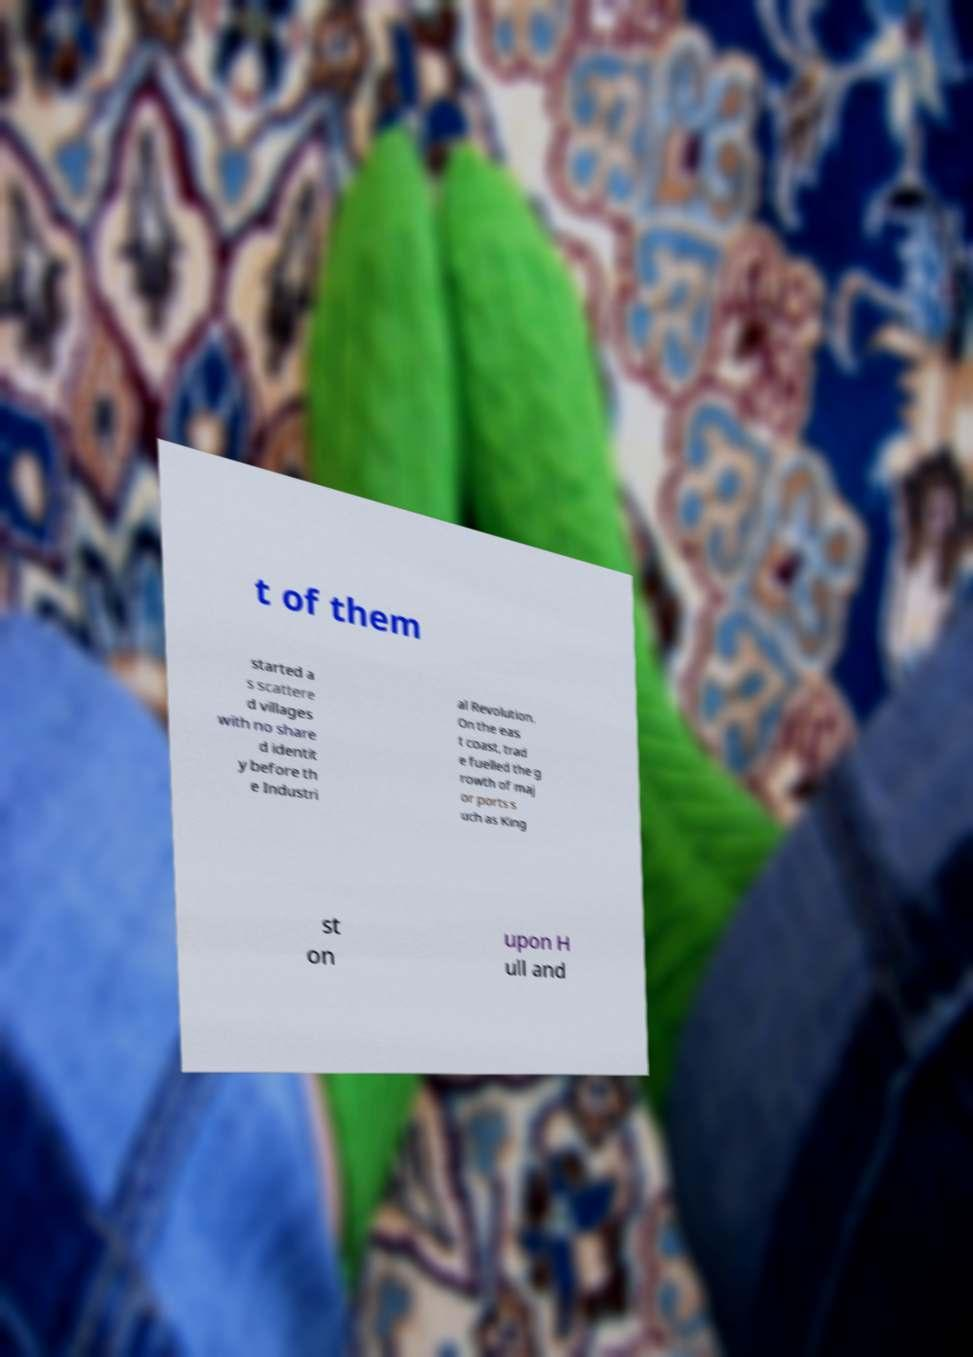What messages or text are displayed in this image? I need them in a readable, typed format. t of them started a s scattere d villages with no share d identit y before th e Industri al Revolution. On the eas t coast, trad e fuelled the g rowth of maj or ports s uch as King st on upon H ull and 